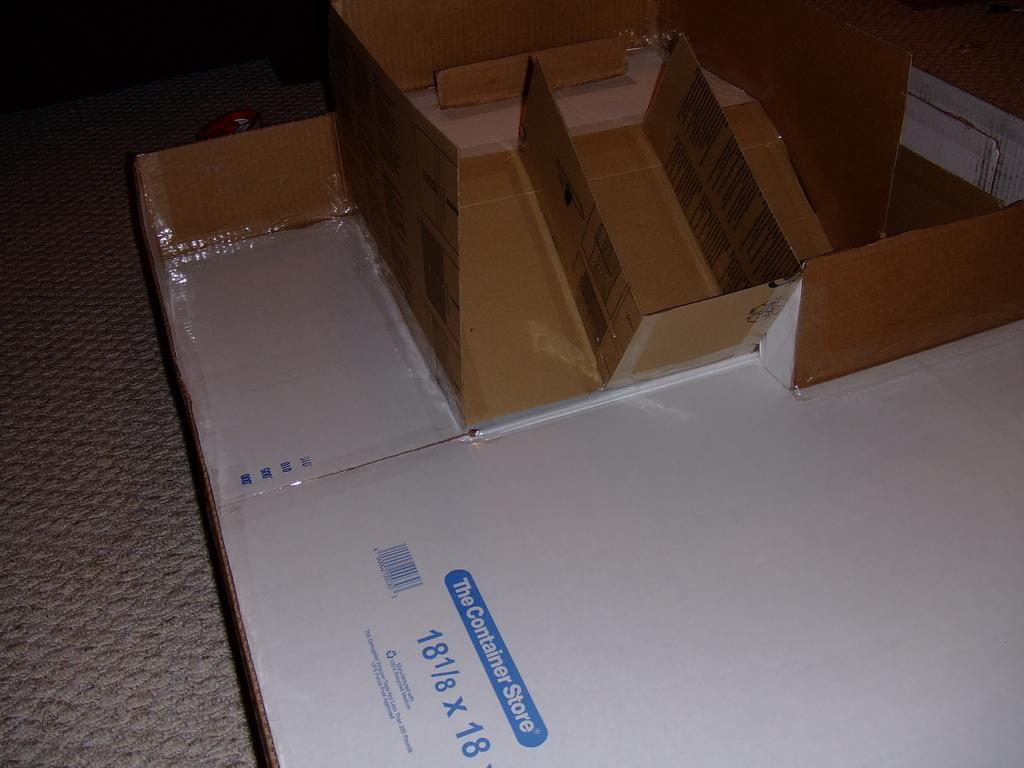<image>
Offer a succinct explanation of the picture presented. A box from the Container Store that is 18 1/8 x 18 